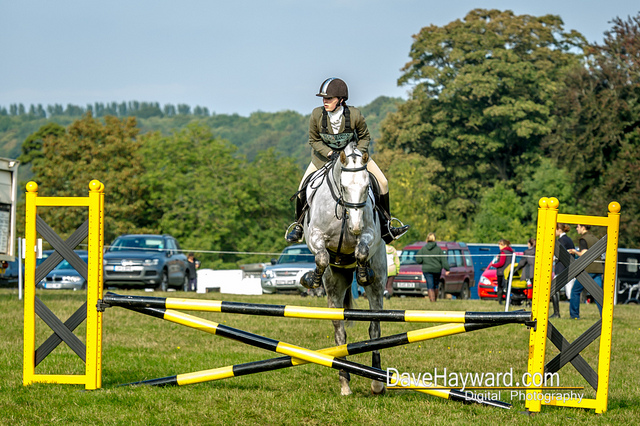Extract all visible text content from this image. DaveHayward.com Digital Photography 